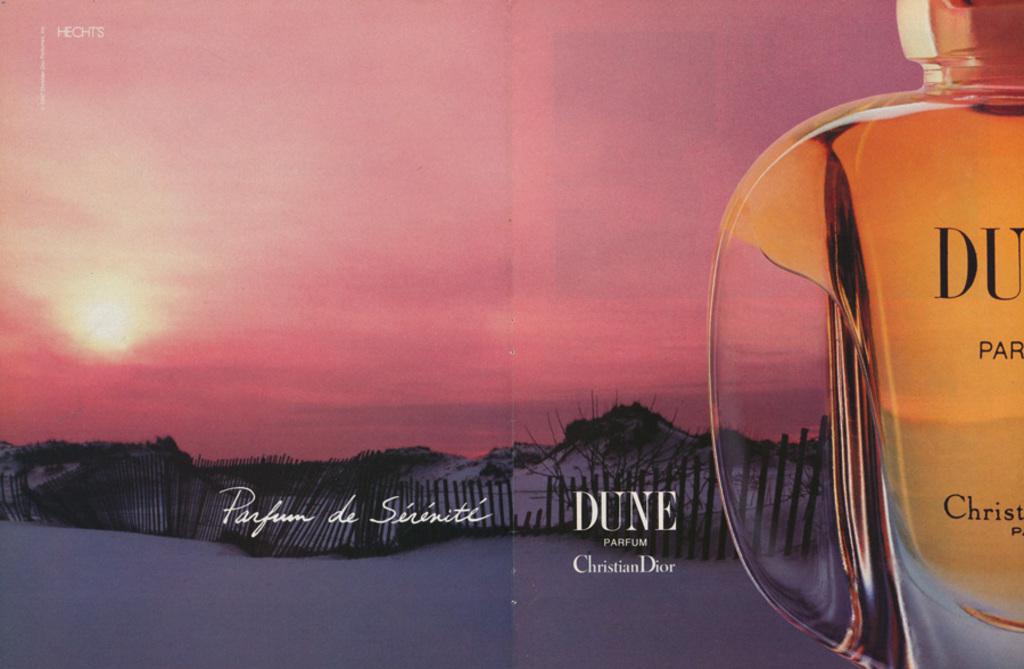Who makes dune?
Give a very brief answer. Christian dior. What is the name of this perfume?
Offer a very short reply. Dune. 